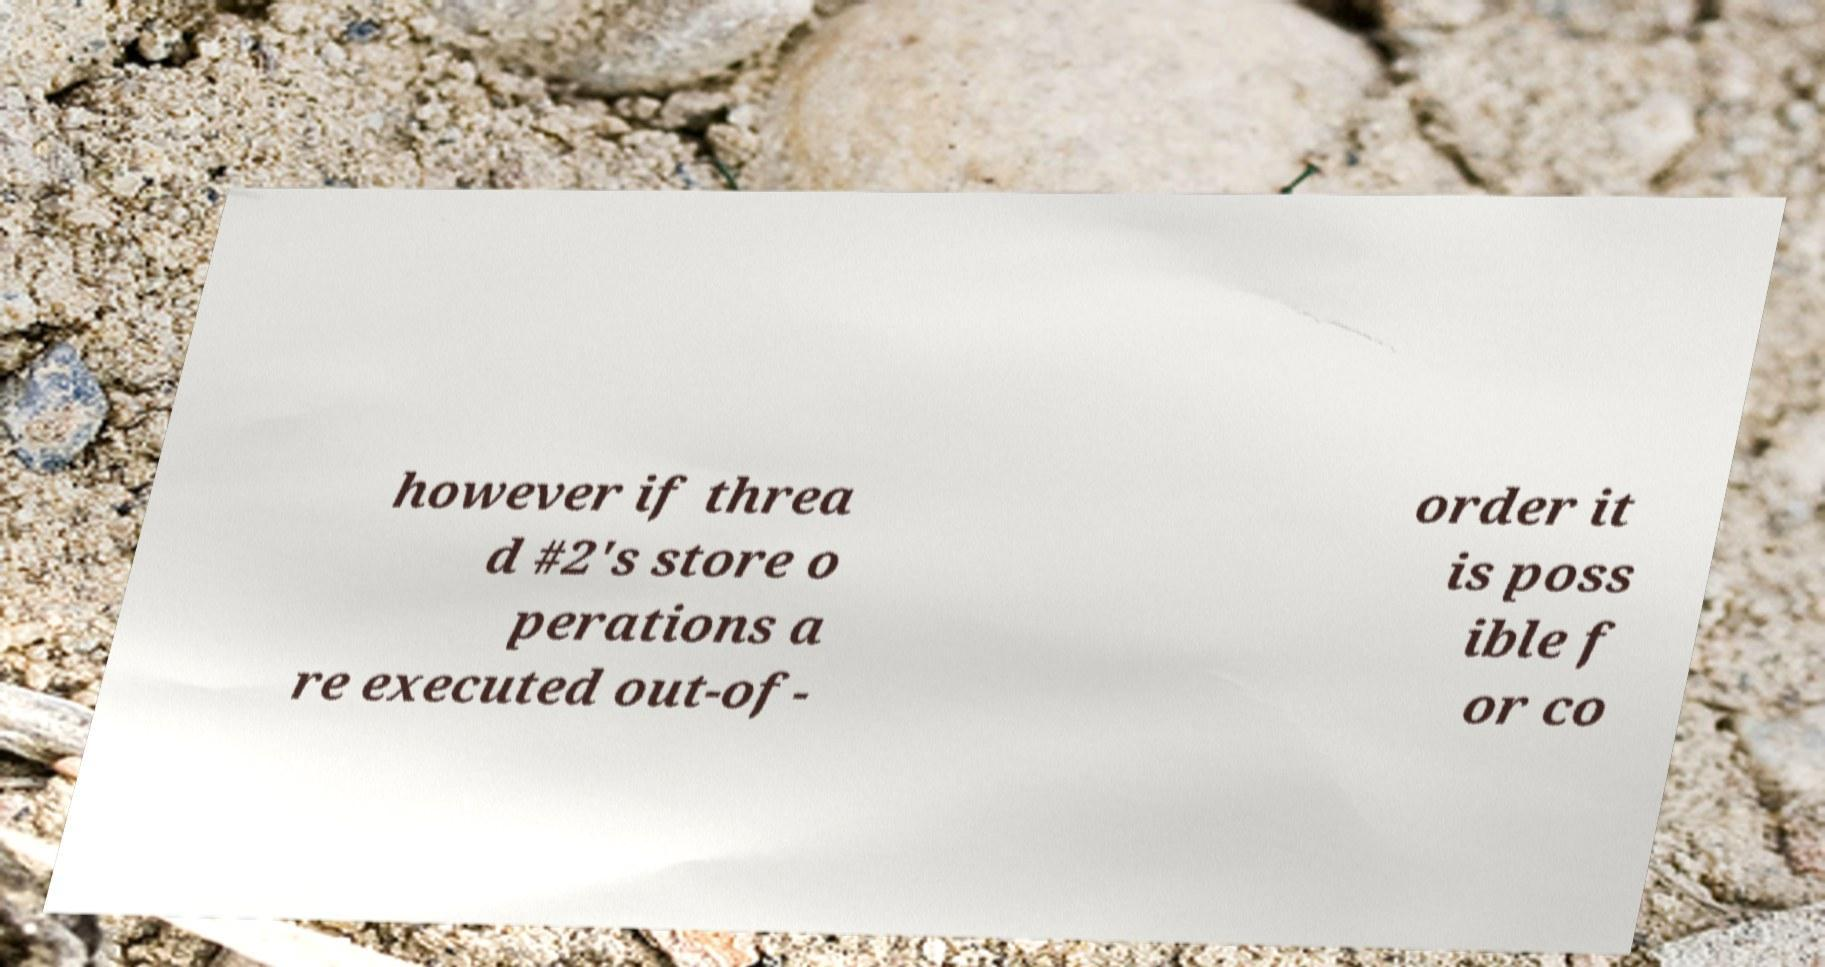What messages or text are displayed in this image? I need them in a readable, typed format. however if threa d #2's store o perations a re executed out-of- order it is poss ible f or co 